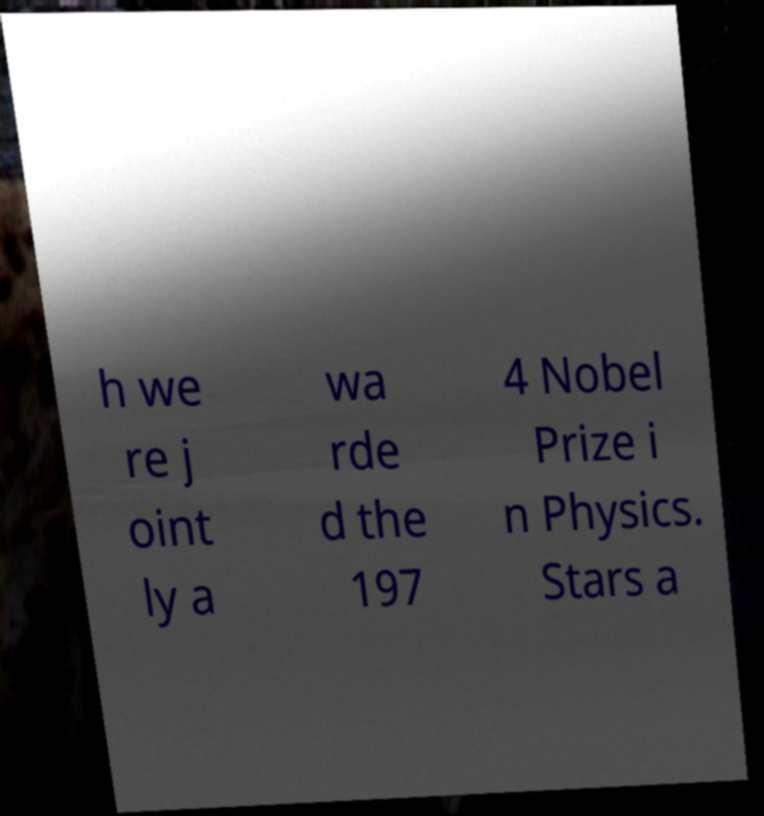Could you assist in decoding the text presented in this image and type it out clearly? h we re j oint ly a wa rde d the 197 4 Nobel Prize i n Physics. Stars a 